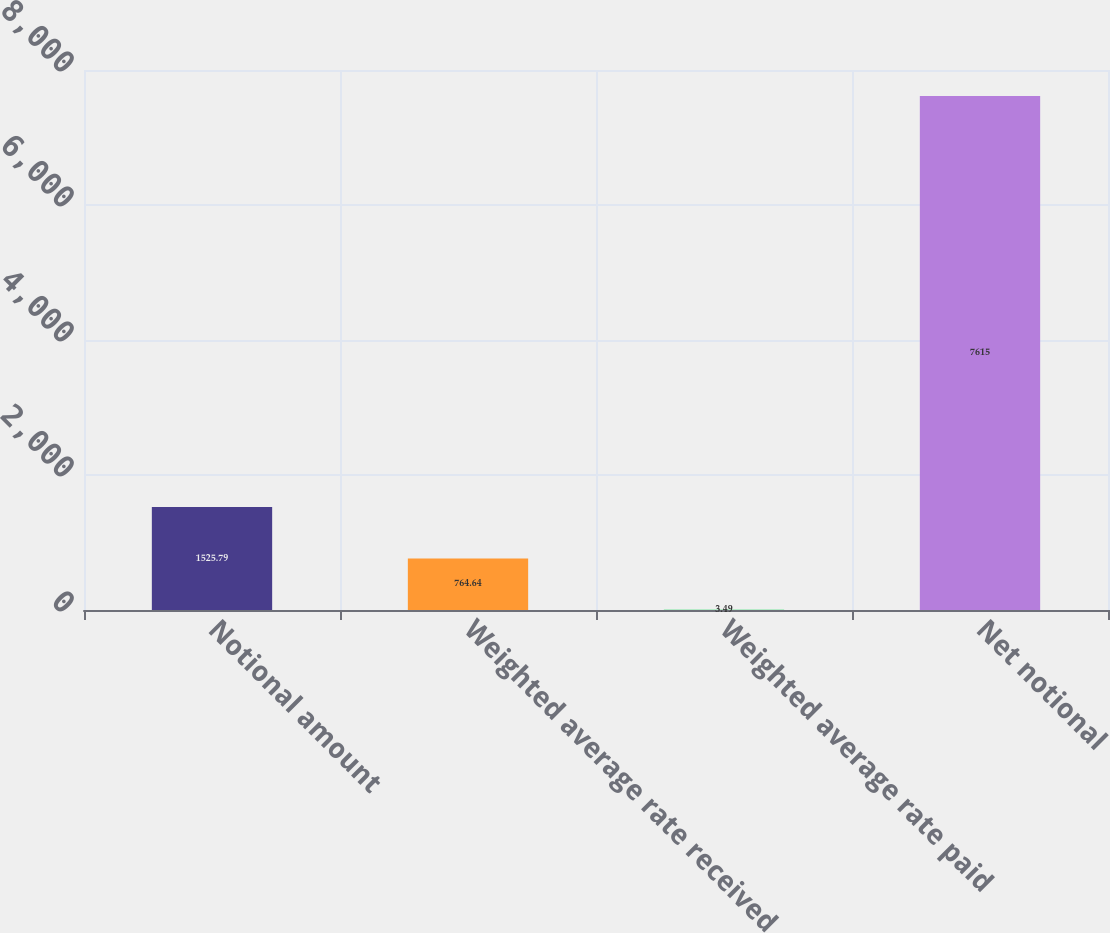Convert chart to OTSL. <chart><loc_0><loc_0><loc_500><loc_500><bar_chart><fcel>Notional amount<fcel>Weighted average rate received<fcel>Weighted average rate paid<fcel>Net notional<nl><fcel>1525.79<fcel>764.64<fcel>3.49<fcel>7615<nl></chart> 